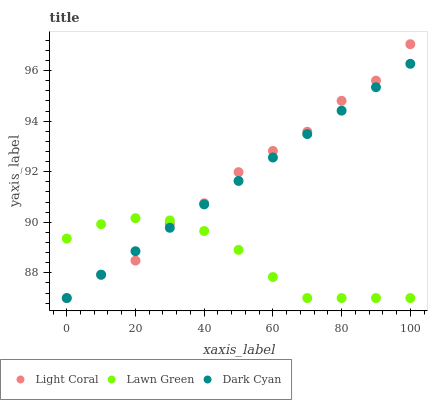Does Lawn Green have the minimum area under the curve?
Answer yes or no. Yes. Does Light Coral have the maximum area under the curve?
Answer yes or no. Yes. Does Dark Cyan have the minimum area under the curve?
Answer yes or no. No. Does Dark Cyan have the maximum area under the curve?
Answer yes or no. No. Is Dark Cyan the smoothest?
Answer yes or no. Yes. Is Light Coral the roughest?
Answer yes or no. Yes. Is Lawn Green the smoothest?
Answer yes or no. No. Is Lawn Green the roughest?
Answer yes or no. No. Does Light Coral have the lowest value?
Answer yes or no. Yes. Does Light Coral have the highest value?
Answer yes or no. Yes. Does Dark Cyan have the highest value?
Answer yes or no. No. Does Light Coral intersect Lawn Green?
Answer yes or no. Yes. Is Light Coral less than Lawn Green?
Answer yes or no. No. Is Light Coral greater than Lawn Green?
Answer yes or no. No. 